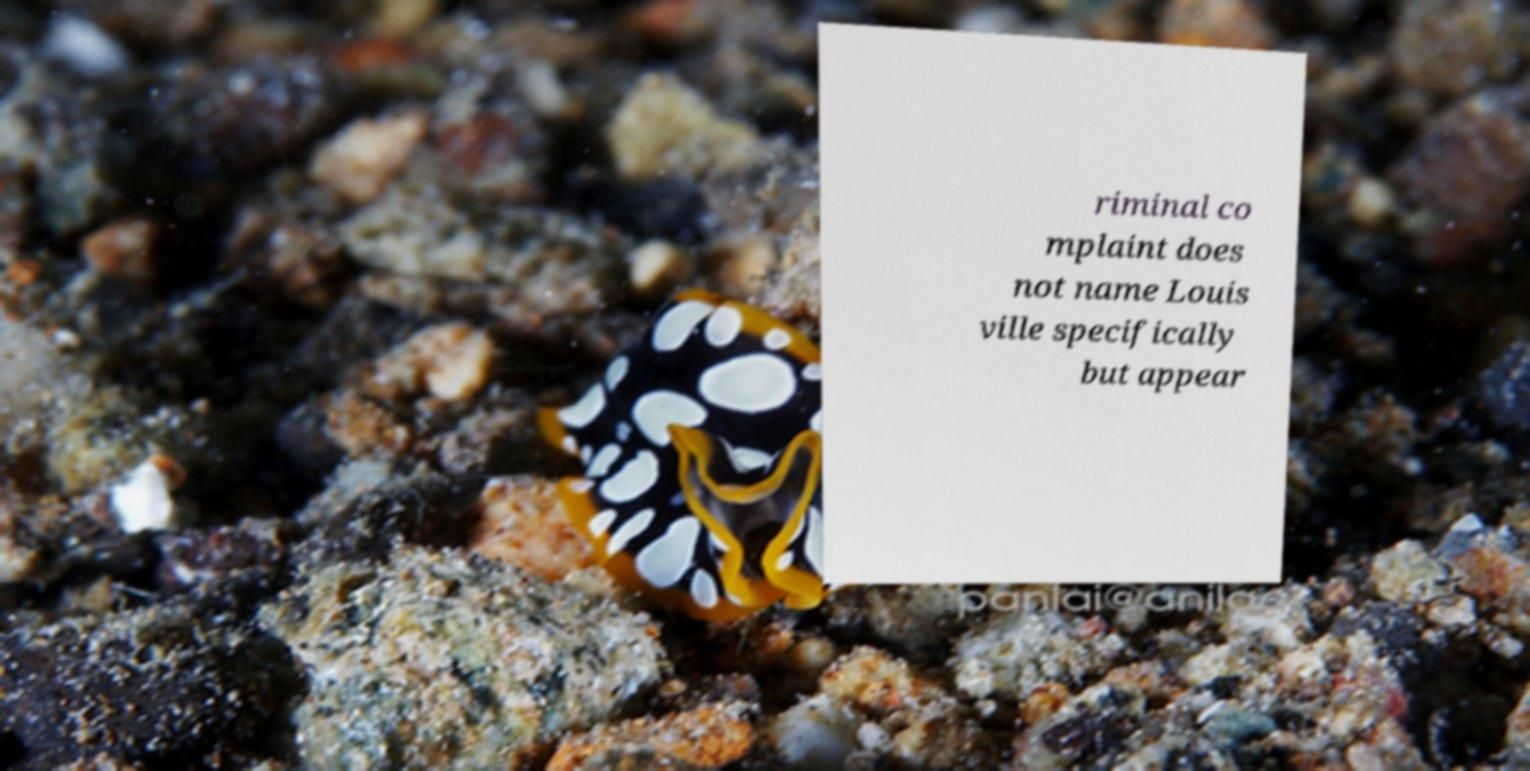Please identify and transcribe the text found in this image. riminal co mplaint does not name Louis ville specifically but appear 